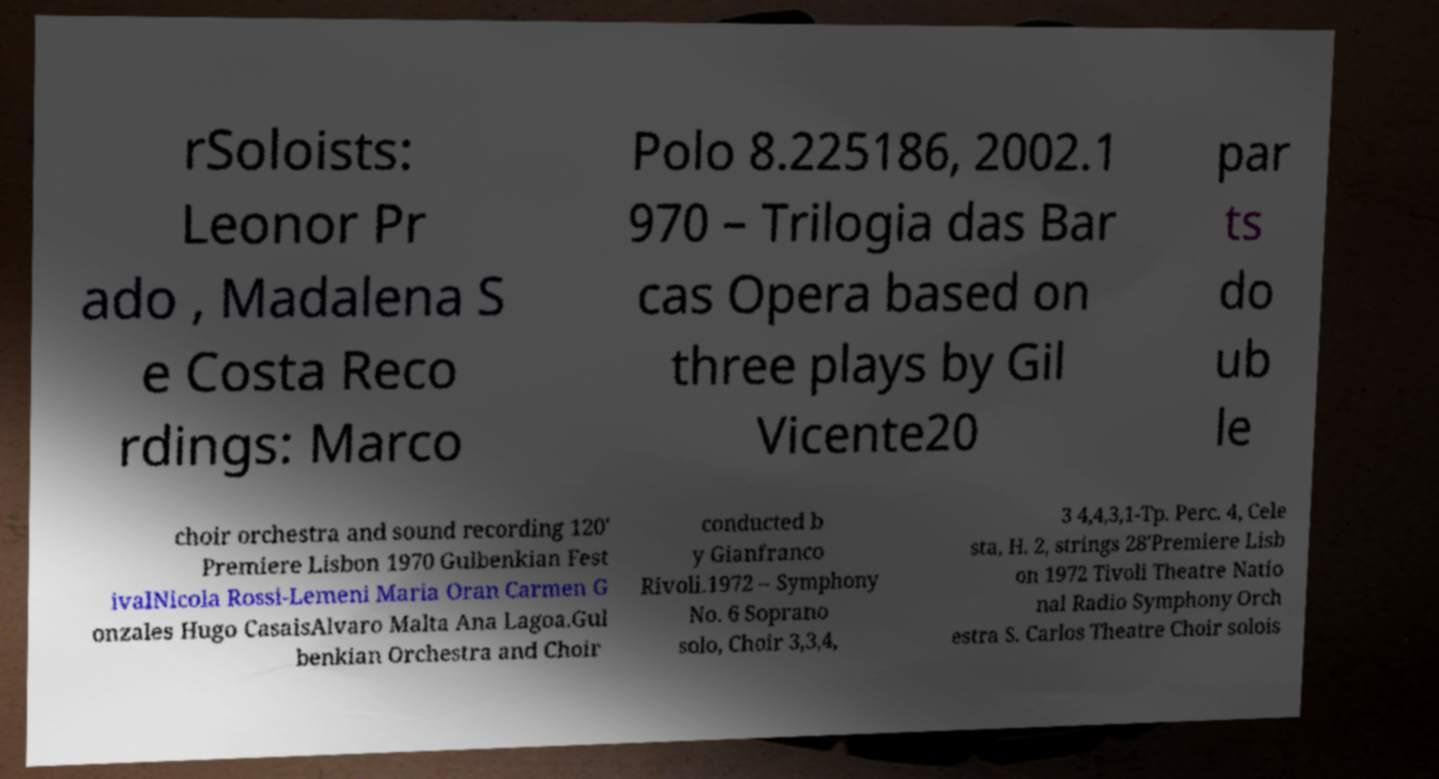Can you accurately transcribe the text from the provided image for me? rSoloists: Leonor Pr ado , Madalena S e Costa Reco rdings: Marco Polo 8.225186, 2002.1 970 – Trilogia das Bar cas Opera based on three plays by Gil Vicente20 par ts do ub le choir orchestra and sound recording 120' Premiere Lisbon 1970 Gulbenkian Fest ivalNicola Rossi-Lemeni Maria Oran Carmen G onzales Hugo CasaisAlvaro Malta Ana Lagoa.Gul benkian Orchestra and Choir conducted b y Gianfranco Rivoli.1972 – Symphony No. 6 Soprano solo, Choir 3,3,4, 3 4,4,3,1-Tp. Perc. 4, Cele sta, H. 2, strings 28'Premiere Lisb on 1972 Tivoli Theatre Natio nal Radio Symphony Orch estra S. Carlos Theatre Choir solois 